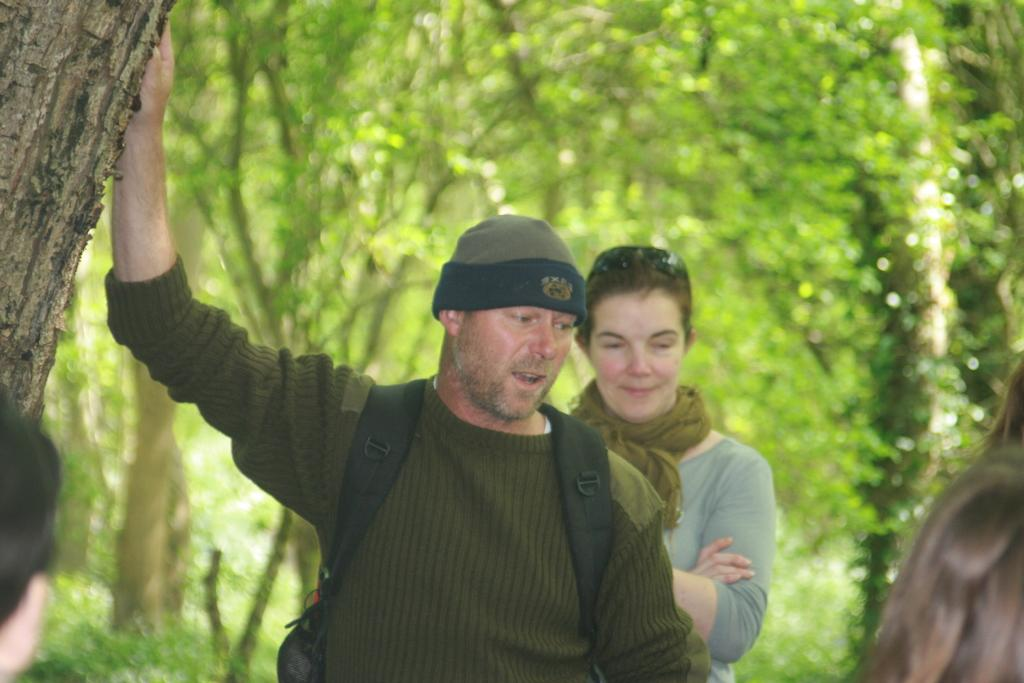How many people are present in the image? There are two people, a man and a woman, present in the image. What are the man and woman doing in the image? The man and woman are standing in the image. What can be seen on the tree in the image? There is the bark of a tree visible in the image. What type of vegetation is present in the image? There is a group of trees visible in the image. What type of harmony can be heard in the image? There is no audible sound in the image, so it is not possible to determine the type of harmony present. 